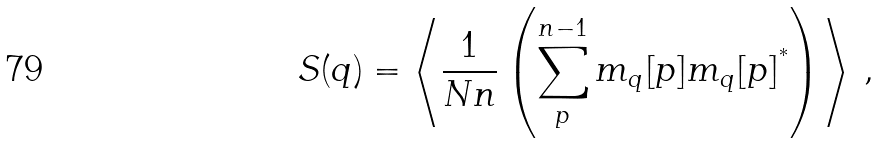<formula> <loc_0><loc_0><loc_500><loc_500>S ( q ) = \left \langle \frac { 1 } { N n } \left ( \sum _ { p } ^ { n - 1 } m _ { q } [ p ] m _ { q } [ p ] ^ { ^ { * } } \right ) \right \rangle \, ,</formula> 